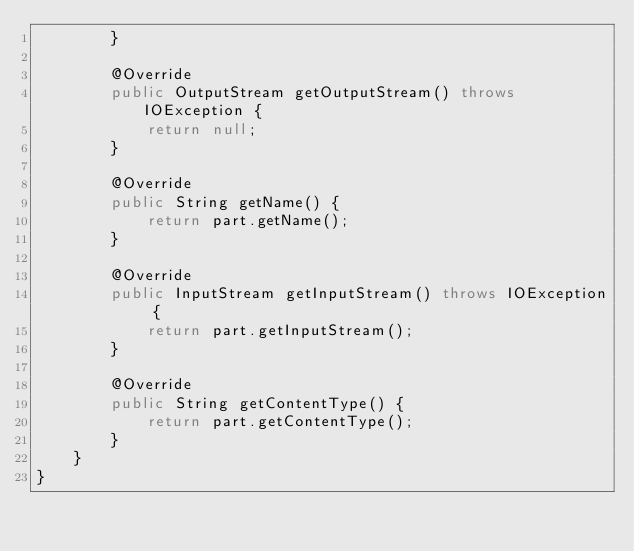Convert code to text. <code><loc_0><loc_0><loc_500><loc_500><_Java_>        }

        @Override
        public OutputStream getOutputStream() throws IOException {
            return null;
        }

        @Override
        public String getName() {
            return part.getName();
        }

        @Override
        public InputStream getInputStream() throws IOException {
            return part.getInputStream();
        }

        @Override
        public String getContentType() {
            return part.getContentType();
        }
    }
}</code> 